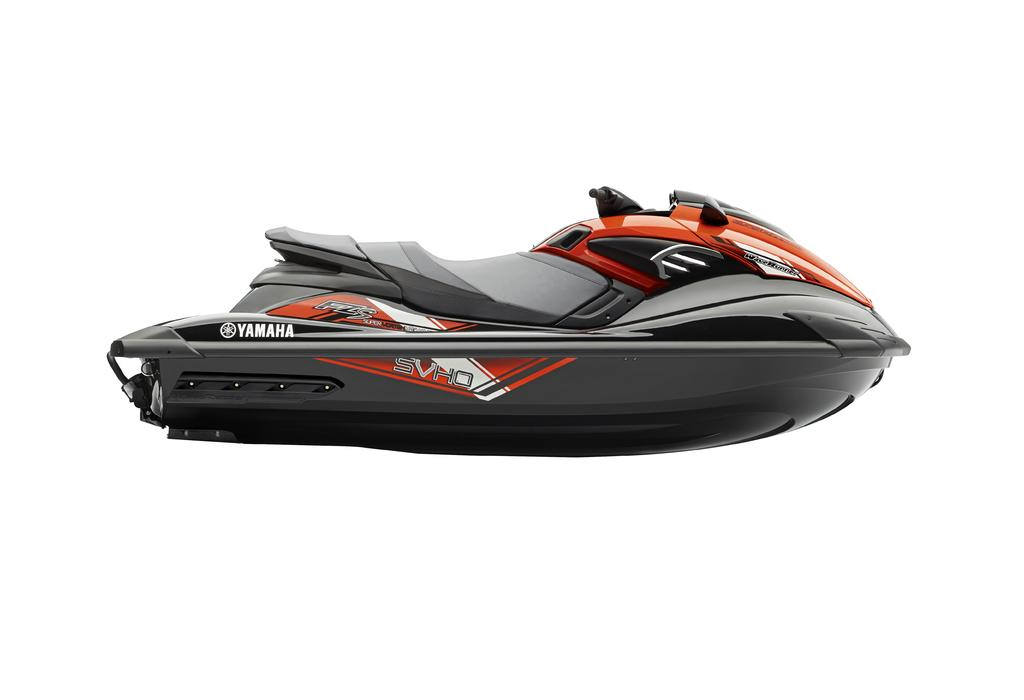What type of vehicle is in the picture? There is a jet ski bike in the picture. What brand is the jet ski bike? The jet ski bike has the brand Yamaha. What colors can be seen on the jet ski bike? The jet ski bike is orange in color, with some parts being gray. How does the nation contribute to the increase in the number of jet ski bikes in the image? There is no nation present in the image, and the number of jet ski bikes is not mentioned. The image only shows one jet ski bike with the brand Yamaha. 